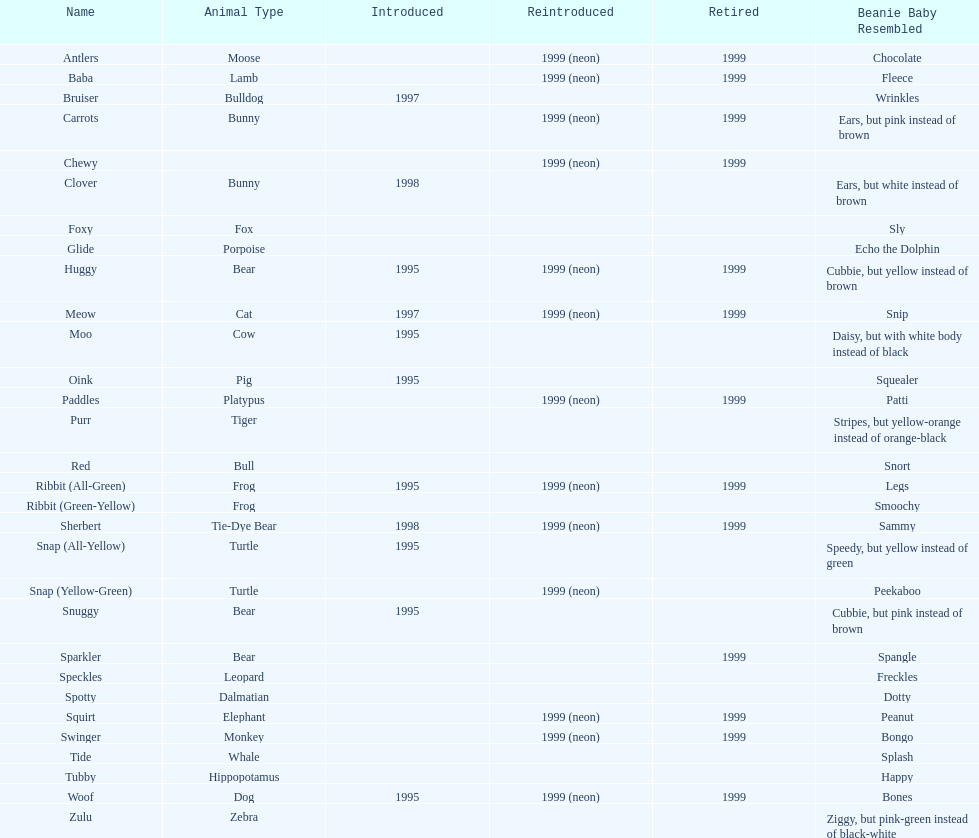What is the number of frog pillow pals? 2. 